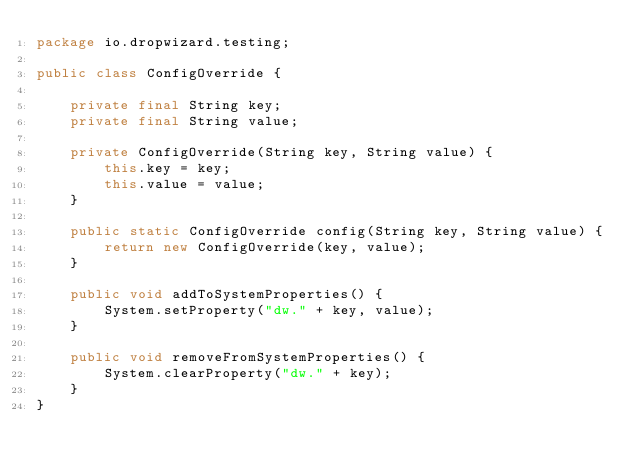<code> <loc_0><loc_0><loc_500><loc_500><_Java_>package io.dropwizard.testing;

public class ConfigOverride {

    private final String key;
    private final String value;

    private ConfigOverride(String key, String value) {
        this.key = key;
        this.value = value;
    }

    public static ConfigOverride config(String key, String value) {
        return new ConfigOverride(key, value);
    }

    public void addToSystemProperties() {
        System.setProperty("dw." + key, value);
    }

    public void removeFromSystemProperties() {
        System.clearProperty("dw." + key);
    }
}
</code> 